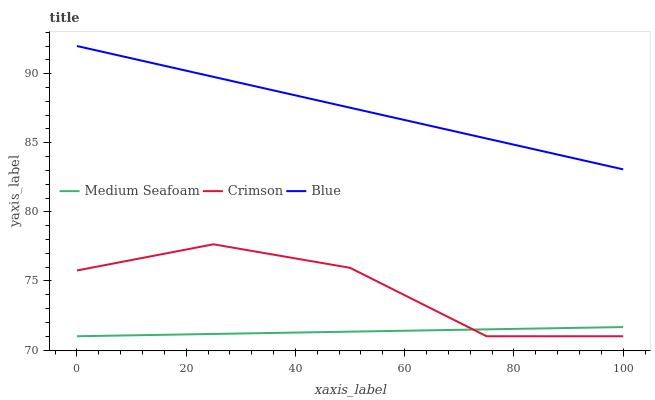Does Medium Seafoam have the minimum area under the curve?
Answer yes or no. Yes. Does Blue have the maximum area under the curve?
Answer yes or no. Yes. Does Blue have the minimum area under the curve?
Answer yes or no. No. Does Medium Seafoam have the maximum area under the curve?
Answer yes or no. No. Is Medium Seafoam the smoothest?
Answer yes or no. Yes. Is Crimson the roughest?
Answer yes or no. Yes. Is Blue the smoothest?
Answer yes or no. No. Is Blue the roughest?
Answer yes or no. No. Does Crimson have the lowest value?
Answer yes or no. Yes. Does Blue have the lowest value?
Answer yes or no. No. Does Blue have the highest value?
Answer yes or no. Yes. Does Medium Seafoam have the highest value?
Answer yes or no. No. Is Crimson less than Blue?
Answer yes or no. Yes. Is Blue greater than Crimson?
Answer yes or no. Yes. Does Crimson intersect Medium Seafoam?
Answer yes or no. Yes. Is Crimson less than Medium Seafoam?
Answer yes or no. No. Is Crimson greater than Medium Seafoam?
Answer yes or no. No. Does Crimson intersect Blue?
Answer yes or no. No. 